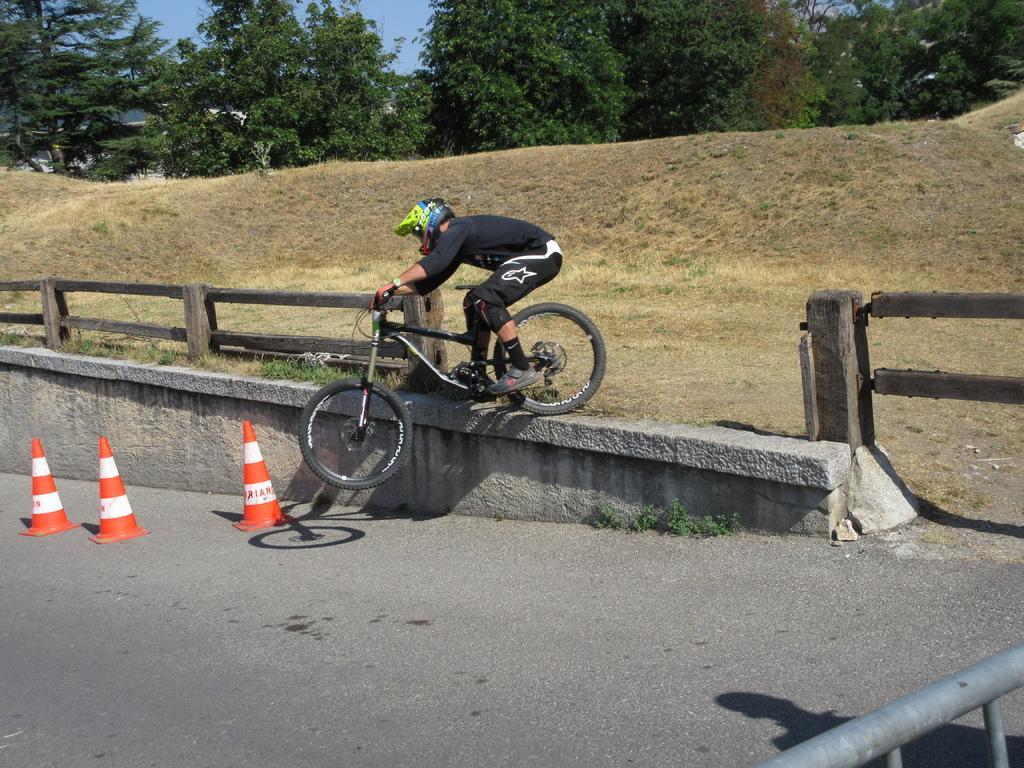Please provide a concise description of this image. In this image we can see a person wearing black color dress, yellow color helmet riding bicycle there are some traffic cones, fencing and at the background of the image there are some trees and clear sky. 